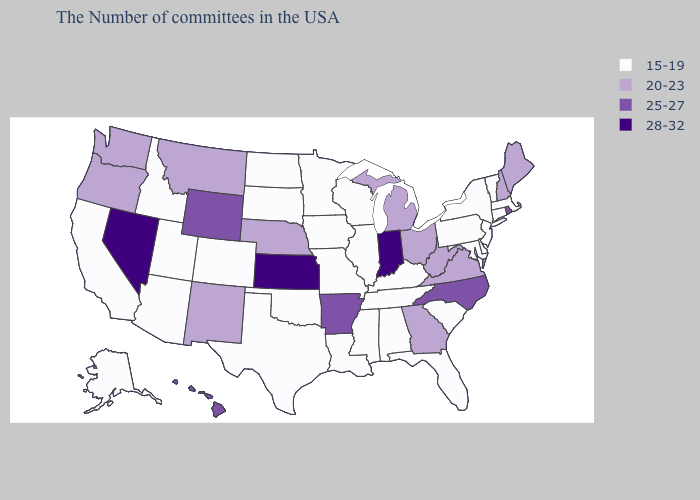What is the highest value in the USA?
Concise answer only. 28-32. What is the lowest value in the Northeast?
Keep it brief. 15-19. What is the value of Montana?
Quick response, please. 20-23. Does the first symbol in the legend represent the smallest category?
Concise answer only. Yes. Does North Carolina have the same value as Rhode Island?
Answer briefly. Yes. Is the legend a continuous bar?
Be succinct. No. What is the value of Utah?
Quick response, please. 15-19. Does Kentucky have the lowest value in the USA?
Be succinct. Yes. Name the states that have a value in the range 15-19?
Answer briefly. Massachusetts, Vermont, Connecticut, New York, New Jersey, Delaware, Maryland, Pennsylvania, South Carolina, Florida, Kentucky, Alabama, Tennessee, Wisconsin, Illinois, Mississippi, Louisiana, Missouri, Minnesota, Iowa, Oklahoma, Texas, South Dakota, North Dakota, Colorado, Utah, Arizona, Idaho, California, Alaska. Does Colorado have the lowest value in the West?
Keep it brief. Yes. What is the value of Idaho?
Answer briefly. 15-19. What is the highest value in states that border Utah?
Give a very brief answer. 28-32. Is the legend a continuous bar?
Give a very brief answer. No. What is the value of Colorado?
Concise answer only. 15-19. What is the lowest value in the USA?
Write a very short answer. 15-19. 